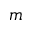<formula> <loc_0><loc_0><loc_500><loc_500>m</formula> 